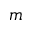<formula> <loc_0><loc_0><loc_500><loc_500>m</formula> 